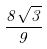<formula> <loc_0><loc_0><loc_500><loc_500>\frac { 8 \sqrt { 3 } } { 9 }</formula> 